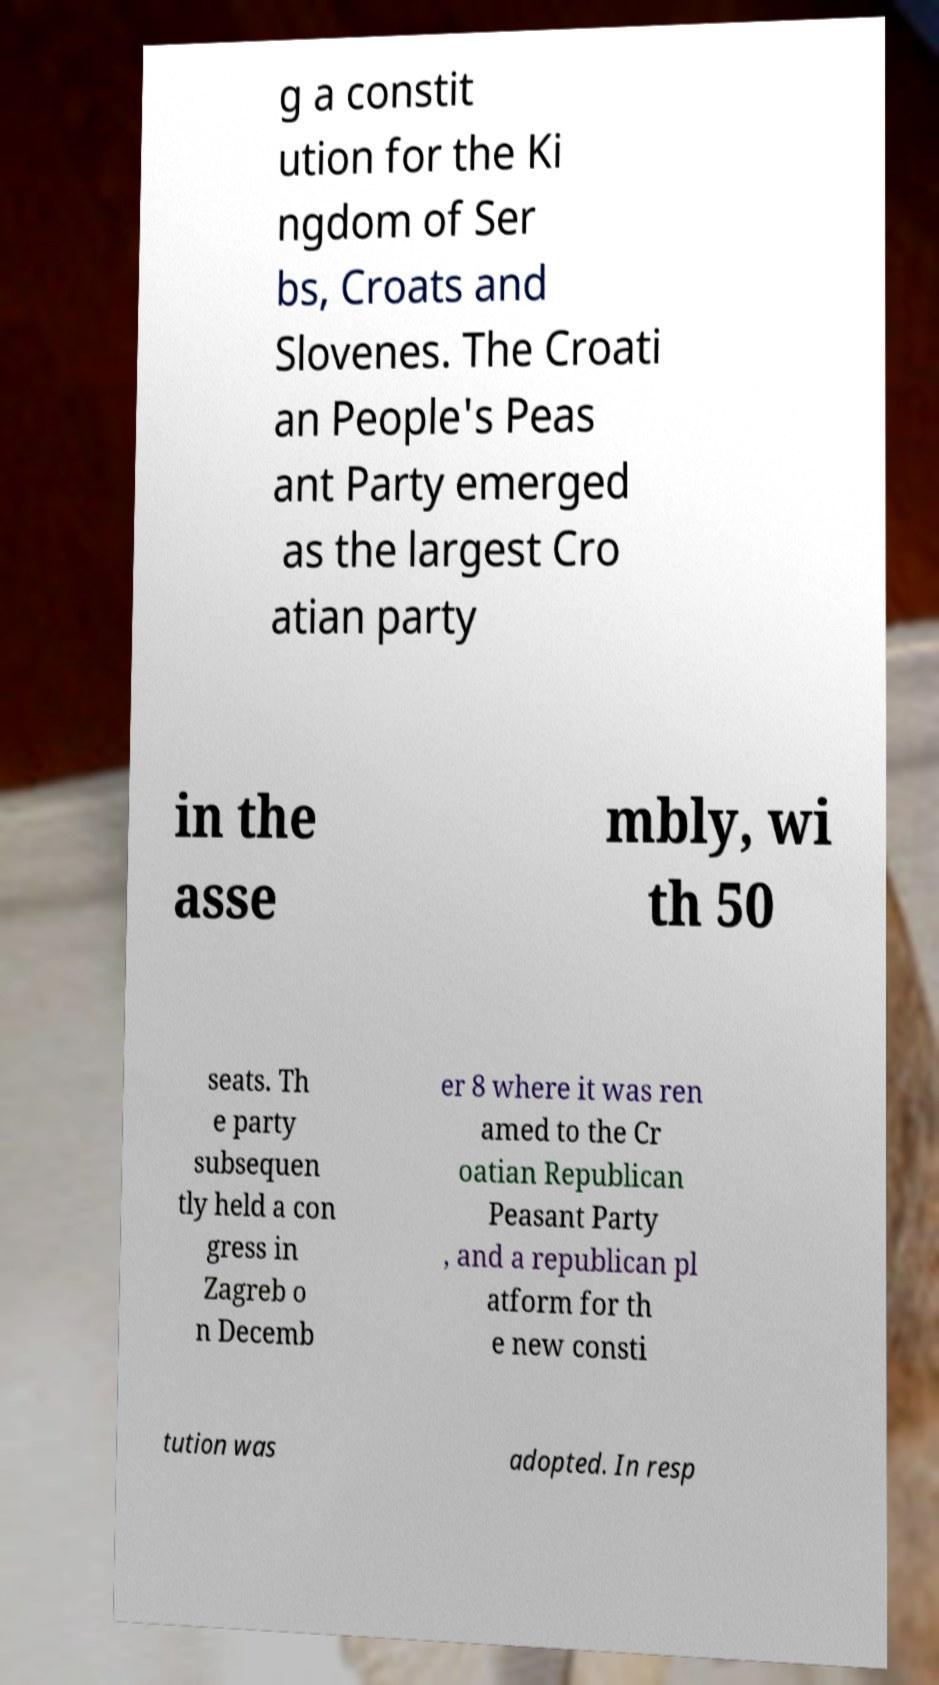There's text embedded in this image that I need extracted. Can you transcribe it verbatim? g a constit ution for the Ki ngdom of Ser bs, Croats and Slovenes. The Croati an People's Peas ant Party emerged as the largest Cro atian party in the asse mbly, wi th 50 seats. Th e party subsequen tly held a con gress in Zagreb o n Decemb er 8 where it was ren amed to the Cr oatian Republican Peasant Party , and a republican pl atform for th e new consti tution was adopted. In resp 